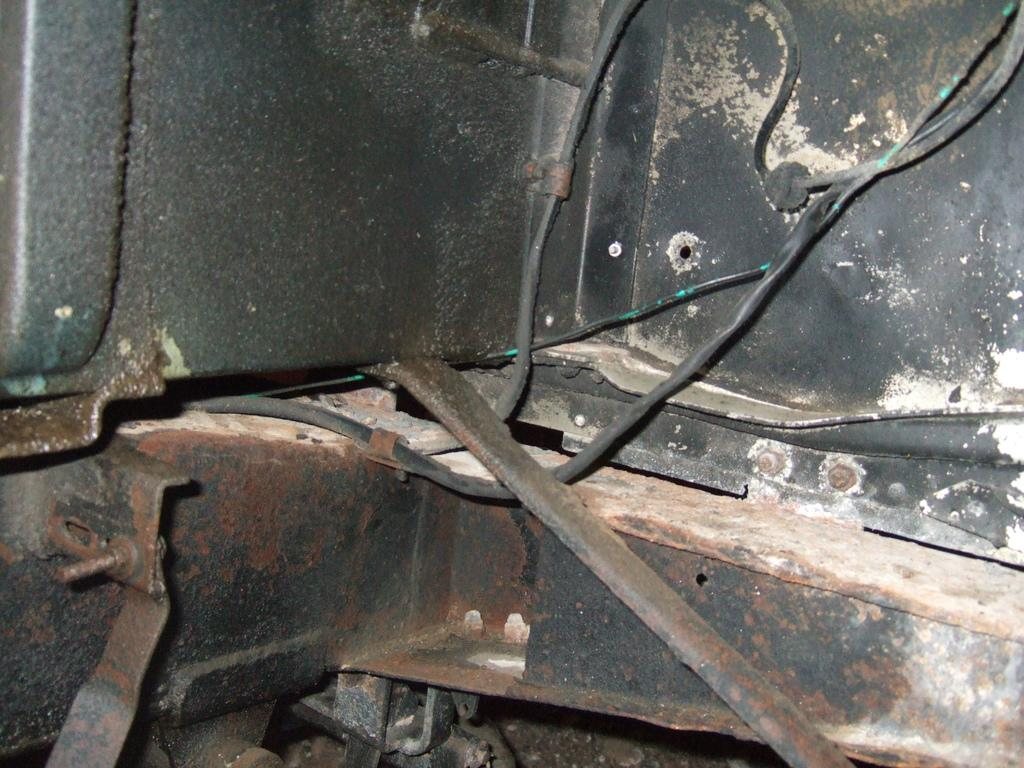What type of material is the main object in the image made of? The main object in the image is made of metal. Are there any additional features connected to the metal object? Yes, there are wires attached to the metal object. What type of muscle can be seen flexing in the image? There is no muscle present in the image; it features a metal object with attached wires. 